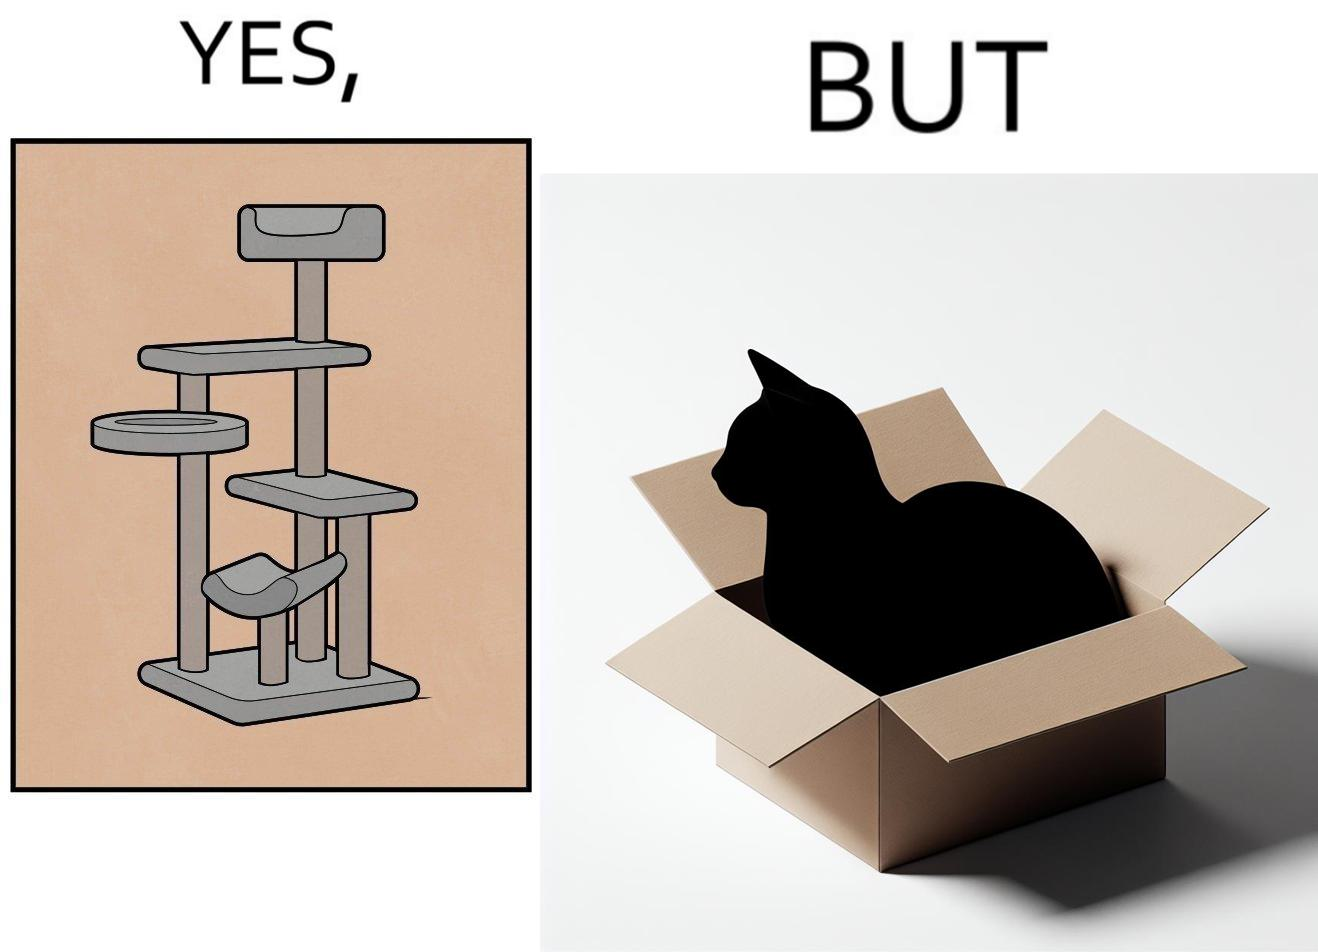Does this image contain satire or humor? Yes, this image is satirical. 